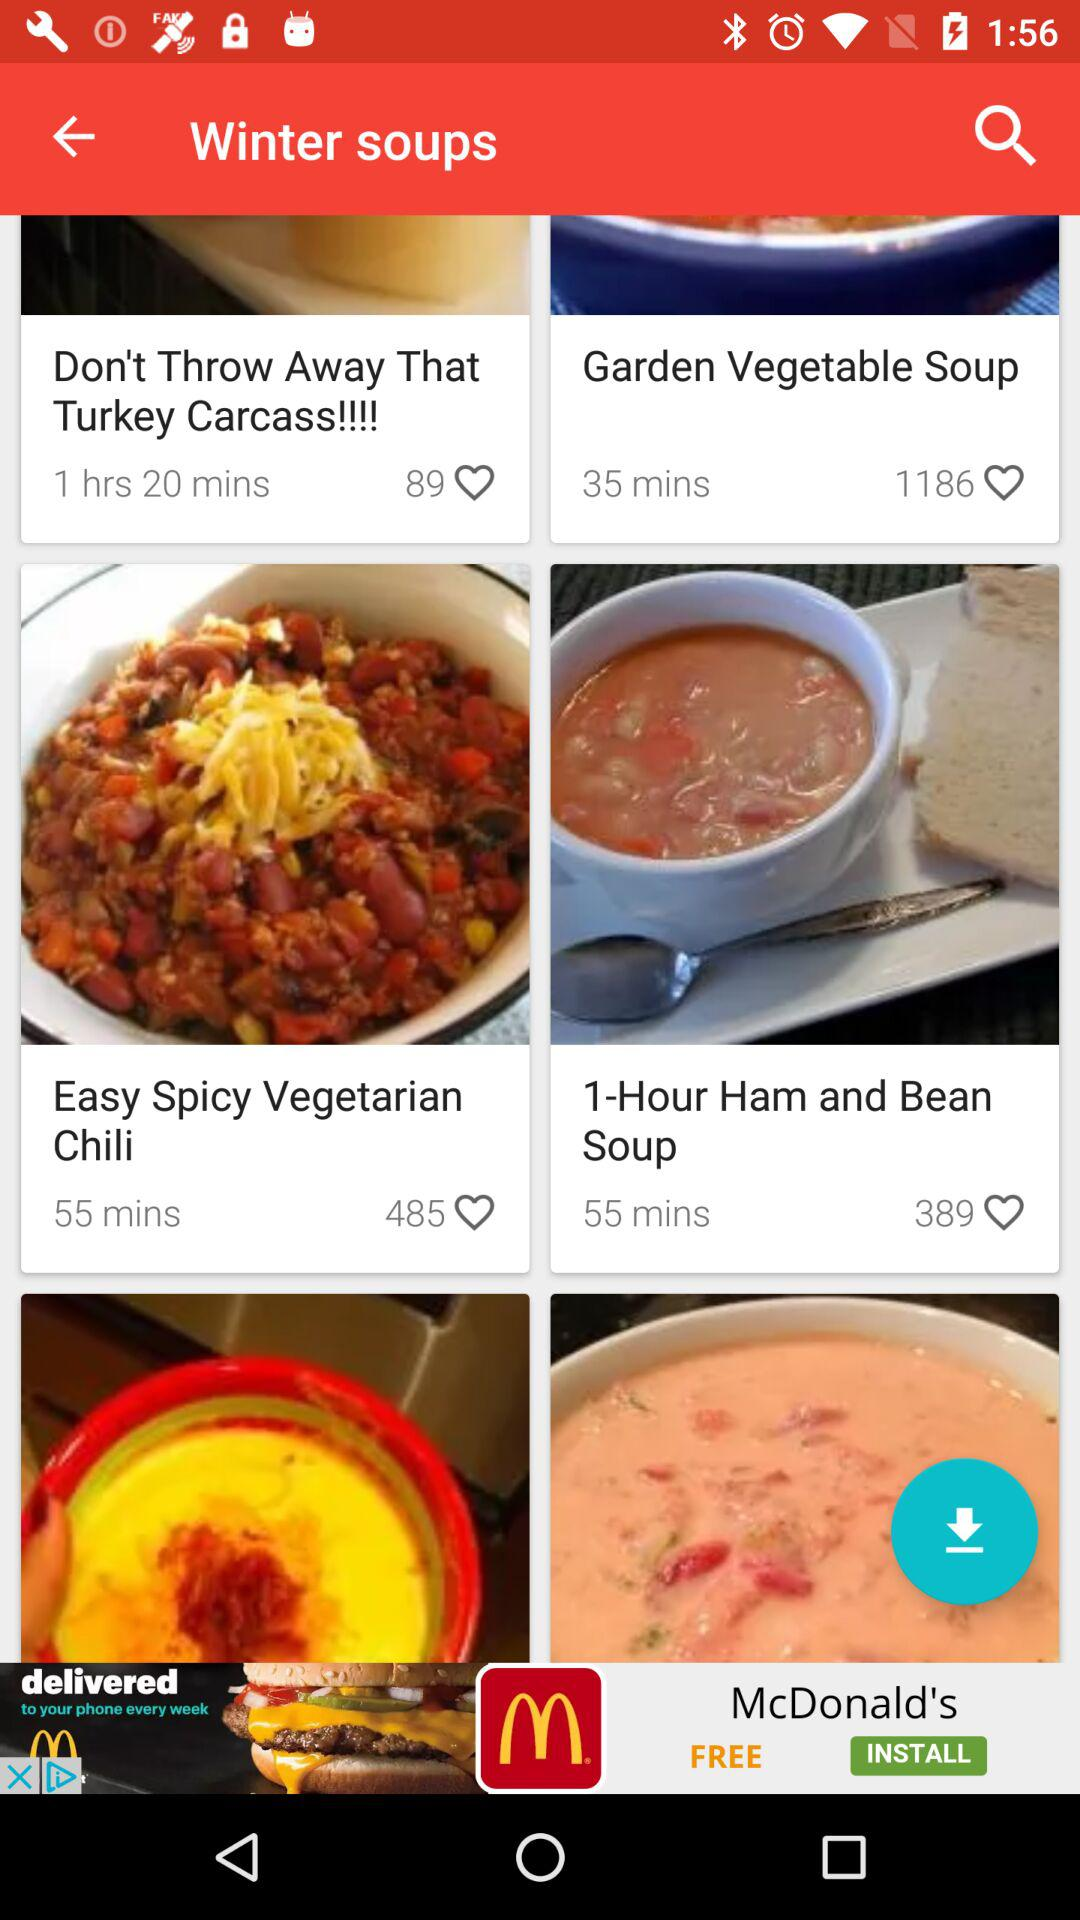How many likes are there on the "Garden Vegetable Soup"? There are 1186 likes on the "Garden Vegetable Soup". 